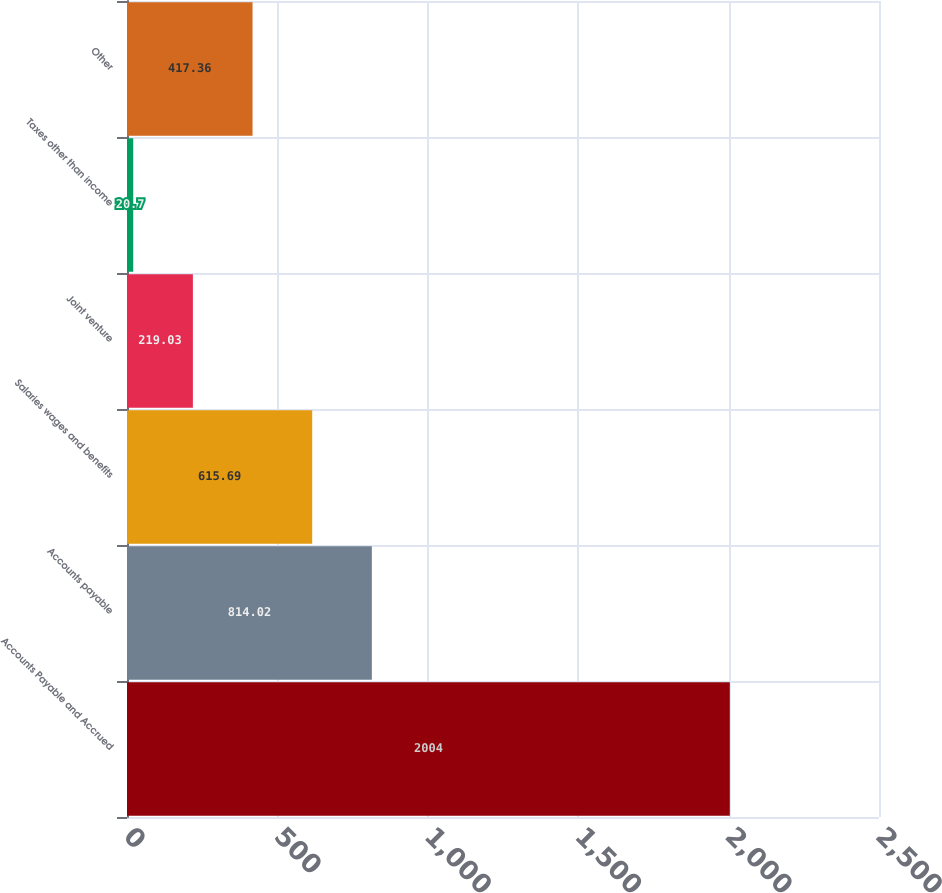Convert chart to OTSL. <chart><loc_0><loc_0><loc_500><loc_500><bar_chart><fcel>Accounts Payable and Accrued<fcel>Accounts payable<fcel>Salaries wages and benefits<fcel>Joint venture<fcel>Taxes other than income<fcel>Other<nl><fcel>2004<fcel>814.02<fcel>615.69<fcel>219.03<fcel>20.7<fcel>417.36<nl></chart> 